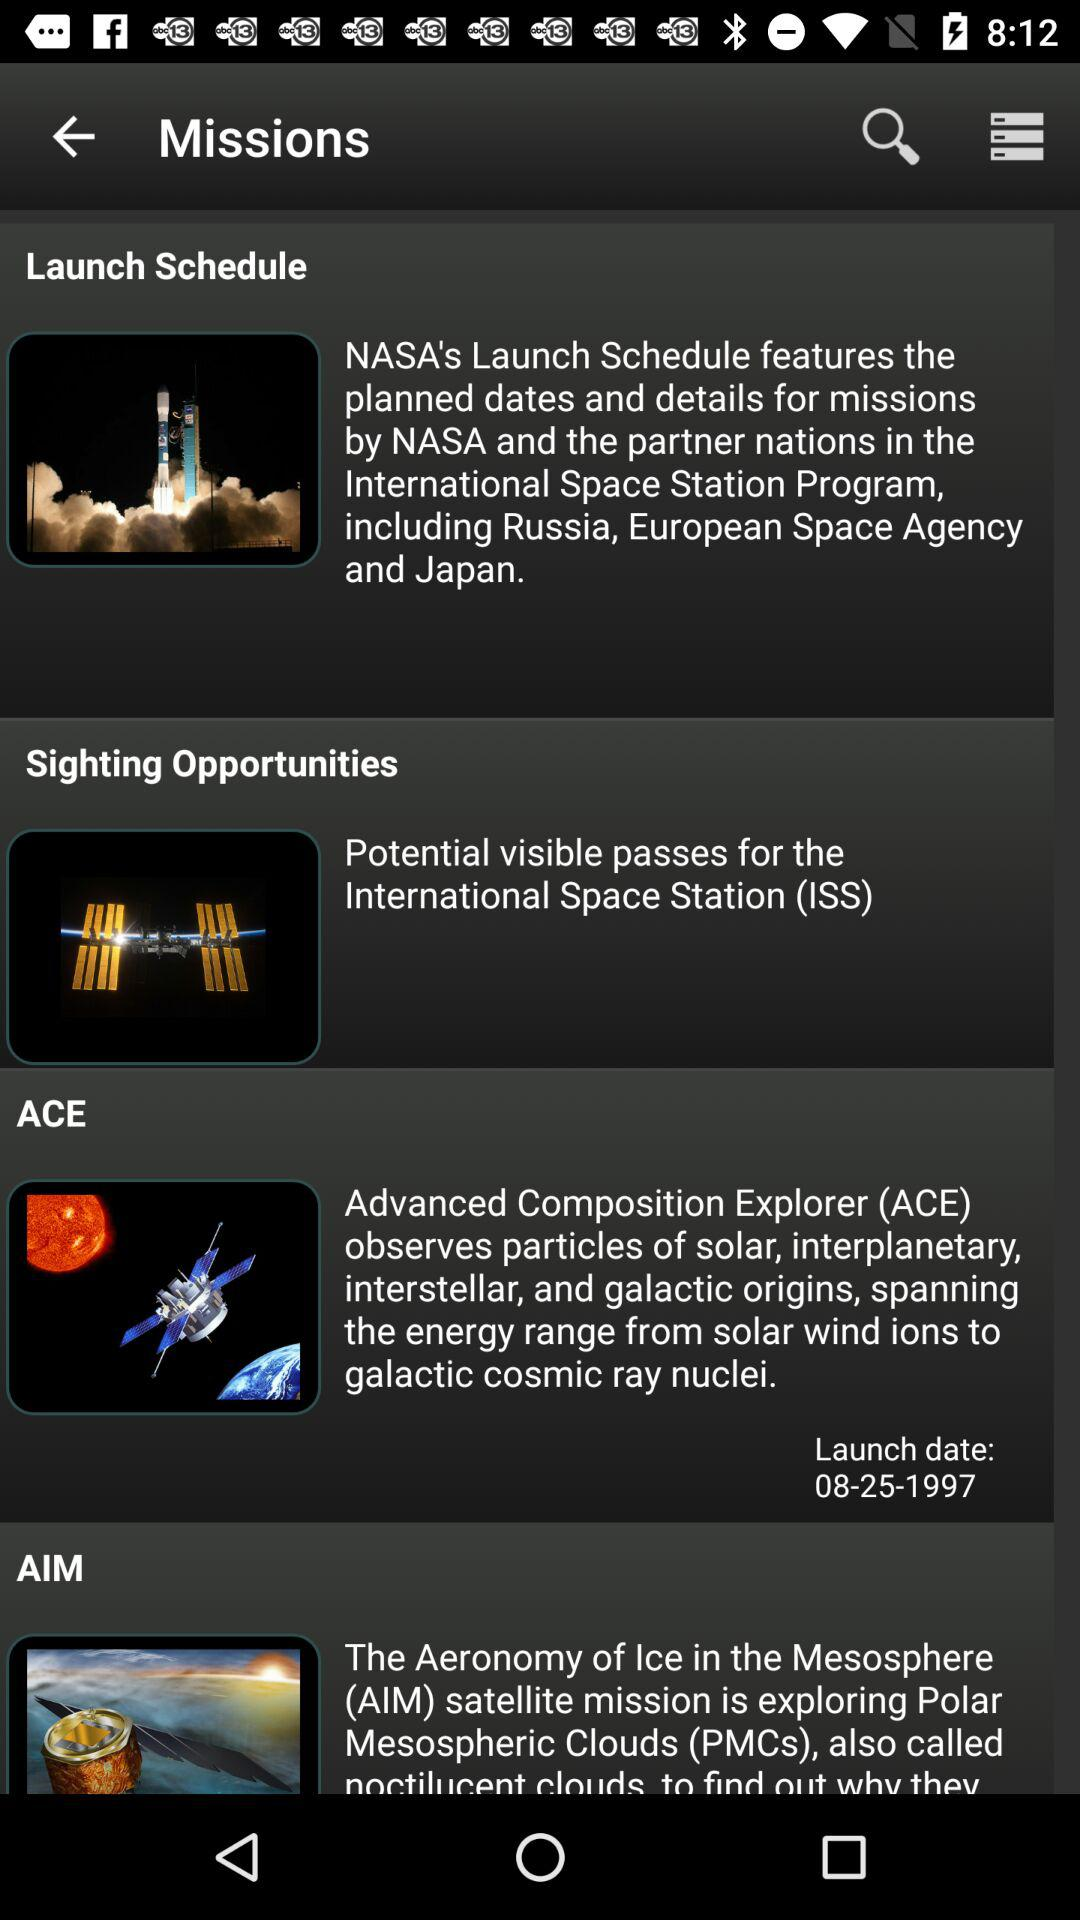What is the launch date of ACE? The launch date is August 25, 1997. 